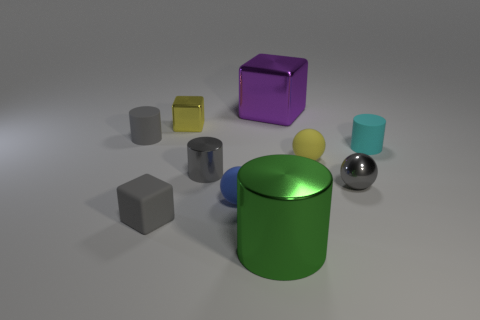Is there any other thing that is the same size as the cyan matte cylinder?
Provide a short and direct response. Yes. Do the small gray thing to the right of the yellow rubber sphere and the large object that is in front of the tiny shiny block have the same shape?
Your response must be concise. No. What is the size of the green cylinder?
Ensure brevity in your answer.  Large. There is a tiny cube that is in front of the gray cylinder that is on the left side of the small gray rubber thing that is in front of the yellow matte thing; what is its material?
Your response must be concise. Rubber. How many other things are the same color as the tiny metallic cylinder?
Offer a terse response. 3. What number of blue objects are either metal balls or tiny cylinders?
Ensure brevity in your answer.  0. There is a small cube behind the tiny gray block; what is its material?
Offer a very short reply. Metal. Are the object that is right of the metal sphere and the gray sphere made of the same material?
Provide a succinct answer. No. What shape is the yellow matte thing?
Give a very brief answer. Sphere. There is a small gray rubber thing behind the gray metal object that is left of the shiny ball; what number of small yellow matte things are behind it?
Provide a short and direct response. 0. 